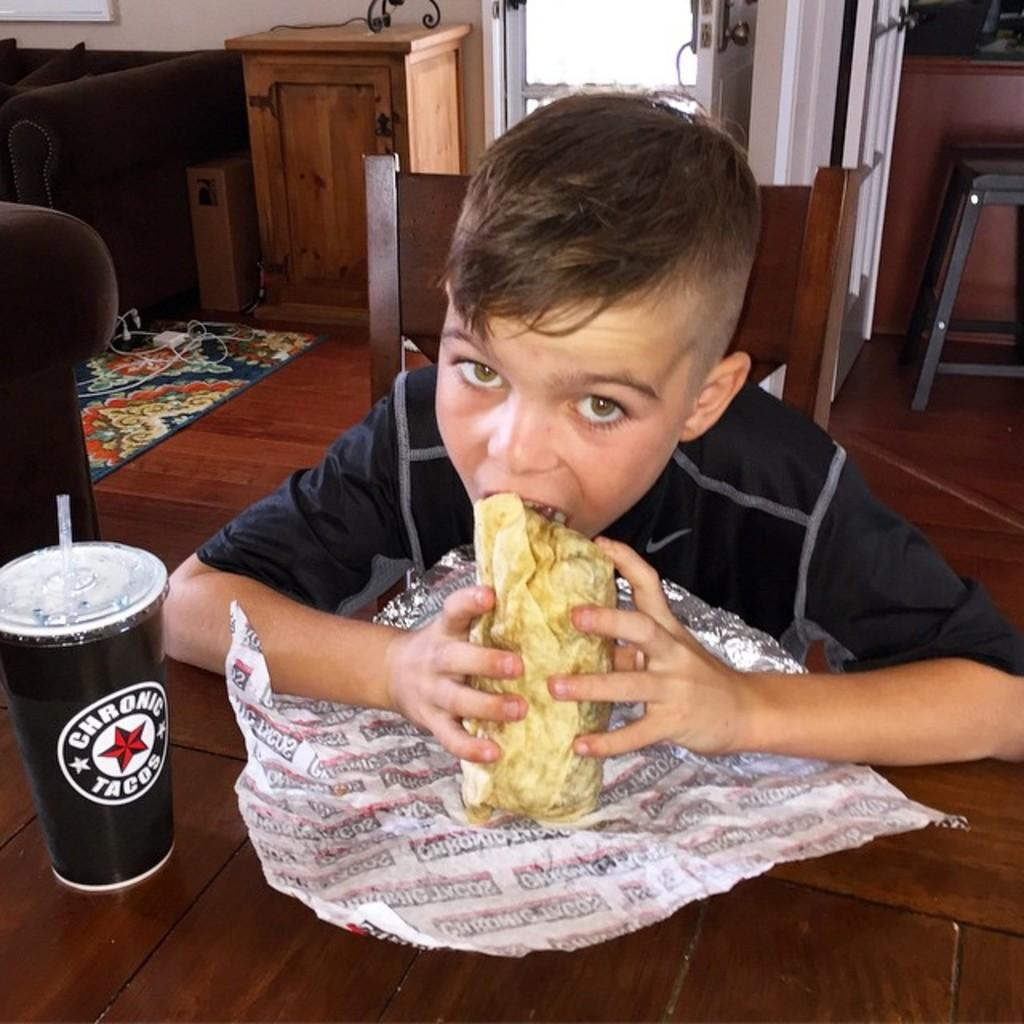What is the boy in the image doing at the table? The boy is sitting at the table and eating food. What can be seen on the table besides the boy? There is a glass on the table. What objects are visible in the background of the image? There is a cupboard, a door, a stool, a sofa, and a wall in the background of the image. What type of railway can be seen in the image? There is no railway present in the image. How does the boy's breath affect the food in the image? The image does not show the boy's breath, so it cannot be determined how it might affect the food. 